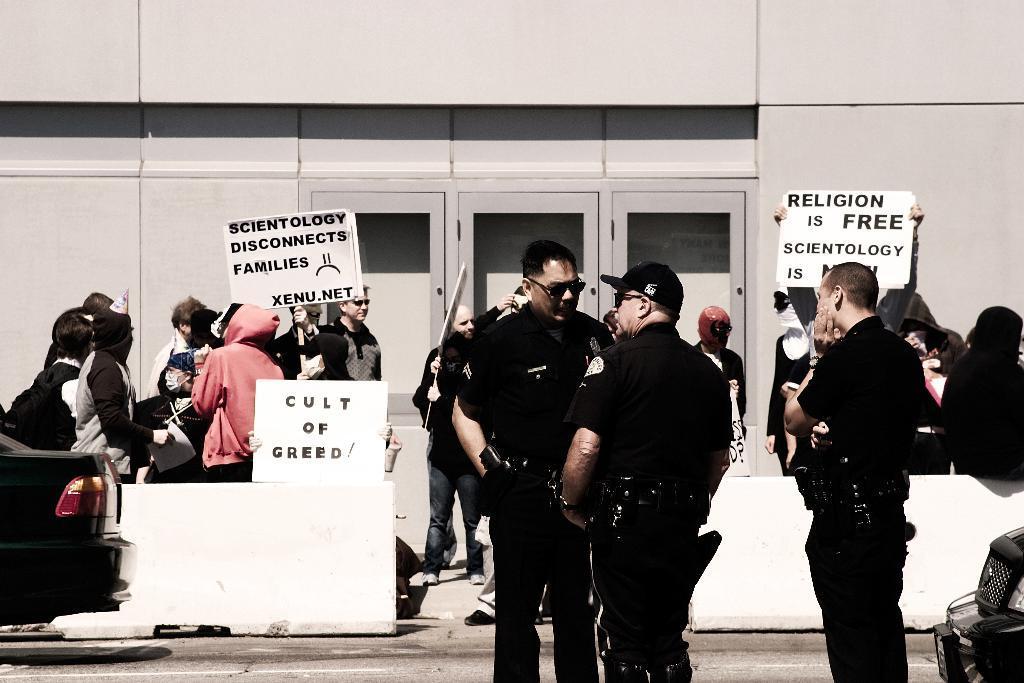Could you give a brief overview of what you see in this image? In this image I can see number of people are standing. I can also see few of them are wearing uniforms and few are holding boards. On these words I can see something is written and here I can see a vehicle. I can also see one more vehicle over here. 